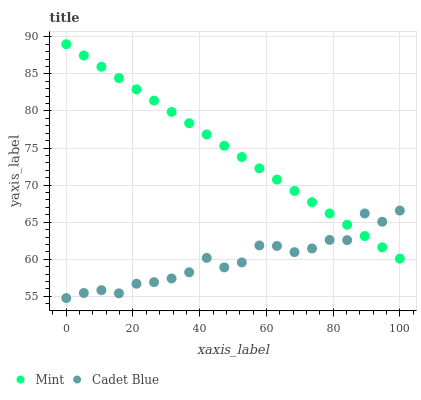Does Cadet Blue have the minimum area under the curve?
Answer yes or no. Yes. Does Mint have the maximum area under the curve?
Answer yes or no. Yes. Does Mint have the minimum area under the curve?
Answer yes or no. No. Is Mint the smoothest?
Answer yes or no. Yes. Is Cadet Blue the roughest?
Answer yes or no. Yes. Is Mint the roughest?
Answer yes or no. No. Does Cadet Blue have the lowest value?
Answer yes or no. Yes. Does Mint have the lowest value?
Answer yes or no. No. Does Mint have the highest value?
Answer yes or no. Yes. Does Cadet Blue intersect Mint?
Answer yes or no. Yes. Is Cadet Blue less than Mint?
Answer yes or no. No. Is Cadet Blue greater than Mint?
Answer yes or no. No. 